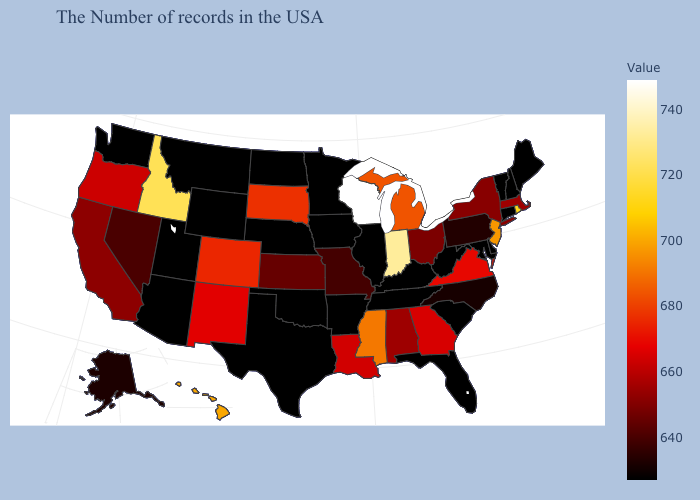Which states have the lowest value in the MidWest?
Short answer required. Illinois, Minnesota, Iowa, Nebraska, North Dakota. Does Hawaii have a lower value than Wisconsin?
Concise answer only. Yes. Does Wisconsin have the lowest value in the MidWest?
Concise answer only. No. 